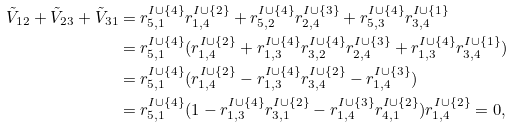Convert formula to latex. <formula><loc_0><loc_0><loc_500><loc_500>\tilde { V } _ { 1 2 } + \tilde { V } _ { 2 3 } + \tilde { V } _ { 3 1 } & = r ^ { I \cup \{ 4 \} } _ { 5 , 1 } r ^ { I \cup \{ 2 \} } _ { 1 , 4 } + r ^ { I \cup \{ 4 \} } _ { 5 , 2 } r ^ { I \cup \{ 3 \} } _ { 2 , 4 } + r ^ { I \cup \{ 4 \} } _ { 5 , 3 } r ^ { I \cup \{ 1 \} } _ { 3 , 4 } \\ & = r ^ { I \cup \{ 4 \} } _ { 5 , 1 } ( r ^ { I \cup \{ 2 \} } _ { 1 , 4 } + r ^ { I \cup \{ 4 \} } _ { 1 , 3 } r ^ { I \cup \{ 4 \} } _ { 3 , 2 } r ^ { I \cup \{ 3 \} } _ { 2 , 4 } + r ^ { I \cup \{ 4 \} } _ { 1 , 3 } r ^ { I \cup \{ 1 \} } _ { 3 , 4 } ) \\ & = r ^ { I \cup \{ 4 \} } _ { 5 , 1 } ( r ^ { I \cup \{ 2 \} } _ { 1 , 4 } - r ^ { I \cup \{ 4 \} } _ { 1 , 3 } r ^ { I \cup \{ 2 \} } _ { 3 , 4 } - r ^ { I \cup \{ 3 \} } _ { 1 , 4 } ) \\ & = r ^ { I \cup \{ 4 \} } _ { 5 , 1 } ( 1 - r ^ { I \cup \{ 4 \} } _ { 1 , 3 } r ^ { I \cup \{ 2 \} } _ { 3 , 1 } - r ^ { I \cup \{ 3 \} } _ { 1 , 4 } r ^ { I \cup \{ 2 \} } _ { 4 , 1 } ) r ^ { I \cup \{ 2 \} } _ { 1 , 4 } = 0 ,</formula> 